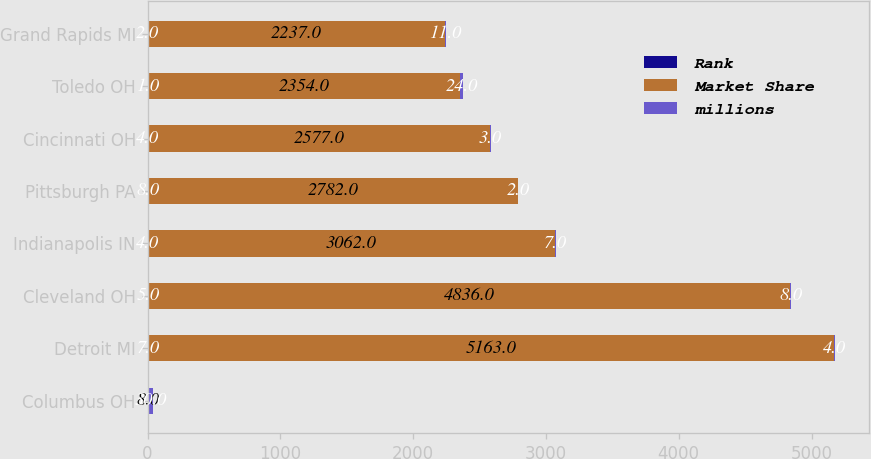Convert chart. <chart><loc_0><loc_0><loc_500><loc_500><stacked_bar_chart><ecel><fcel>Columbus OH<fcel>Detroit MI<fcel>Cleveland OH<fcel>Indianapolis IN<fcel>Pittsburgh PA<fcel>Cincinnati OH<fcel>Toledo OH<fcel>Grand Rapids MI<nl><fcel>Rank<fcel>1<fcel>7<fcel>5<fcel>4<fcel>8<fcel>4<fcel>1<fcel>2<nl><fcel>Market Share<fcel>8<fcel>5163<fcel>4836<fcel>3062<fcel>2782<fcel>2577<fcel>2354<fcel>2237<nl><fcel>millions<fcel>30<fcel>4<fcel>8<fcel>7<fcel>2<fcel>3<fcel>24<fcel>11<nl></chart> 